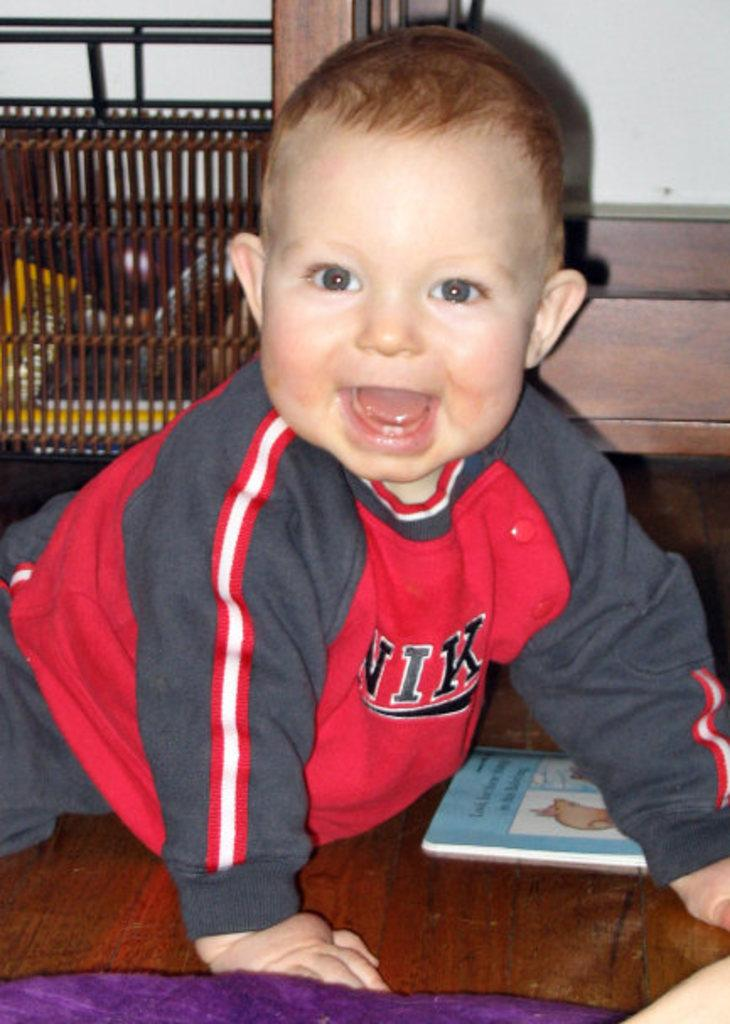<image>
Relay a brief, clear account of the picture shown. baby wearing red and gray nike outfit crawling on the floor  next to an illustrated book 